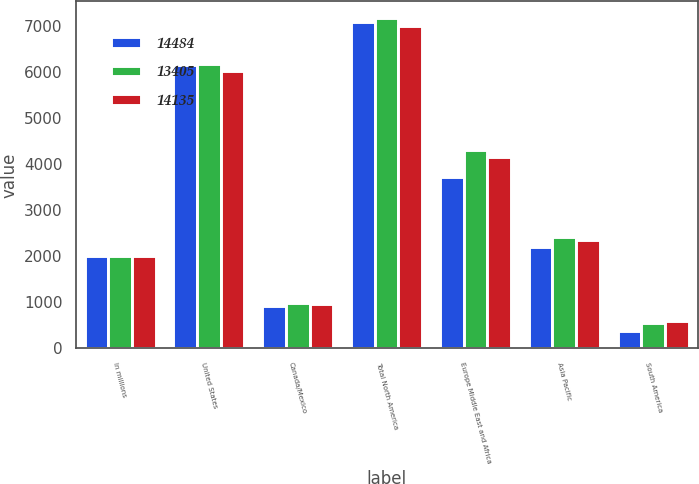<chart> <loc_0><loc_0><loc_500><loc_500><stacked_bar_chart><ecel><fcel>In millions<fcel>United States<fcel>Canada/Mexico<fcel>Total North America<fcel>Europe Middle East and Africa<fcel>Asia Pacific<fcel>South America<nl><fcel>14484<fcel>2015<fcel>6167<fcel>928<fcel>7095<fcel>3725<fcel>2197<fcel>388<nl><fcel>13405<fcel>2014<fcel>6191<fcel>993<fcel>7184<fcel>4319<fcel>2427<fcel>554<nl><fcel>14135<fcel>2013<fcel>6030<fcel>973<fcel>7003<fcel>4162<fcel>2366<fcel>604<nl></chart> 